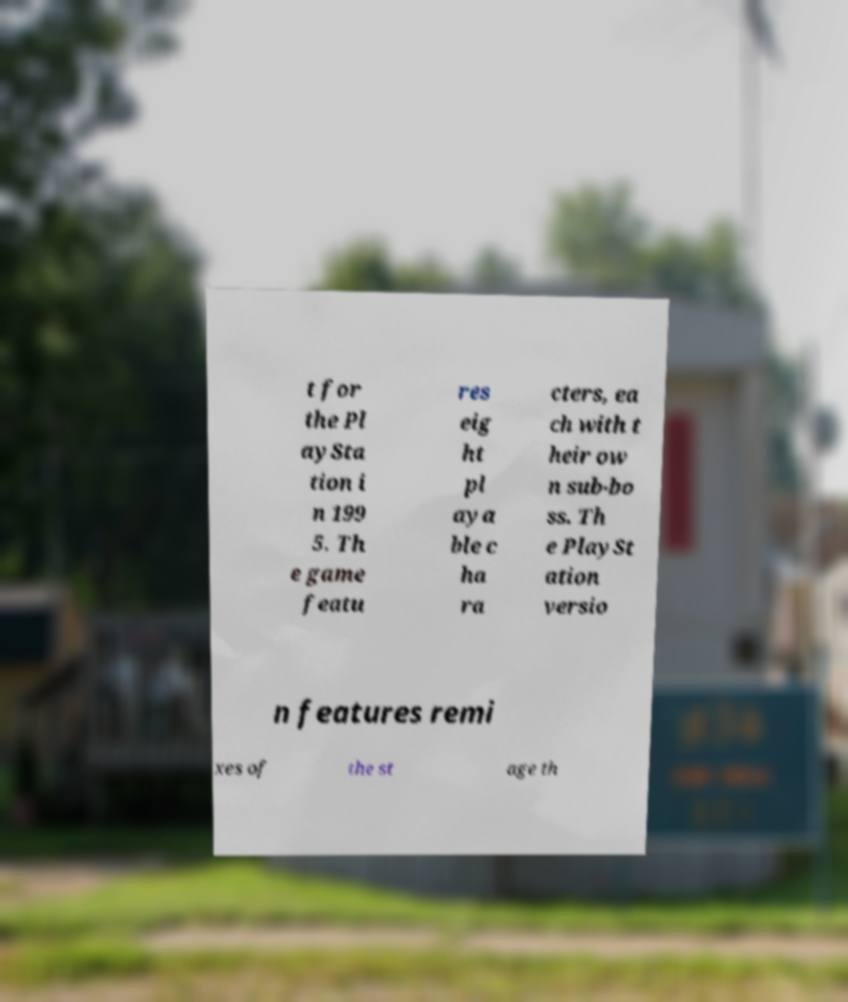I need the written content from this picture converted into text. Can you do that? t for the Pl aySta tion i n 199 5. Th e game featu res eig ht pl aya ble c ha ra cters, ea ch with t heir ow n sub-bo ss. Th e PlaySt ation versio n features remi xes of the st age th 